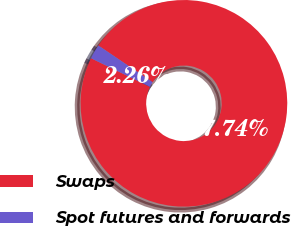Convert chart. <chart><loc_0><loc_0><loc_500><loc_500><pie_chart><fcel>Swaps<fcel>Spot futures and forwards<nl><fcel>97.74%<fcel>2.26%<nl></chart> 